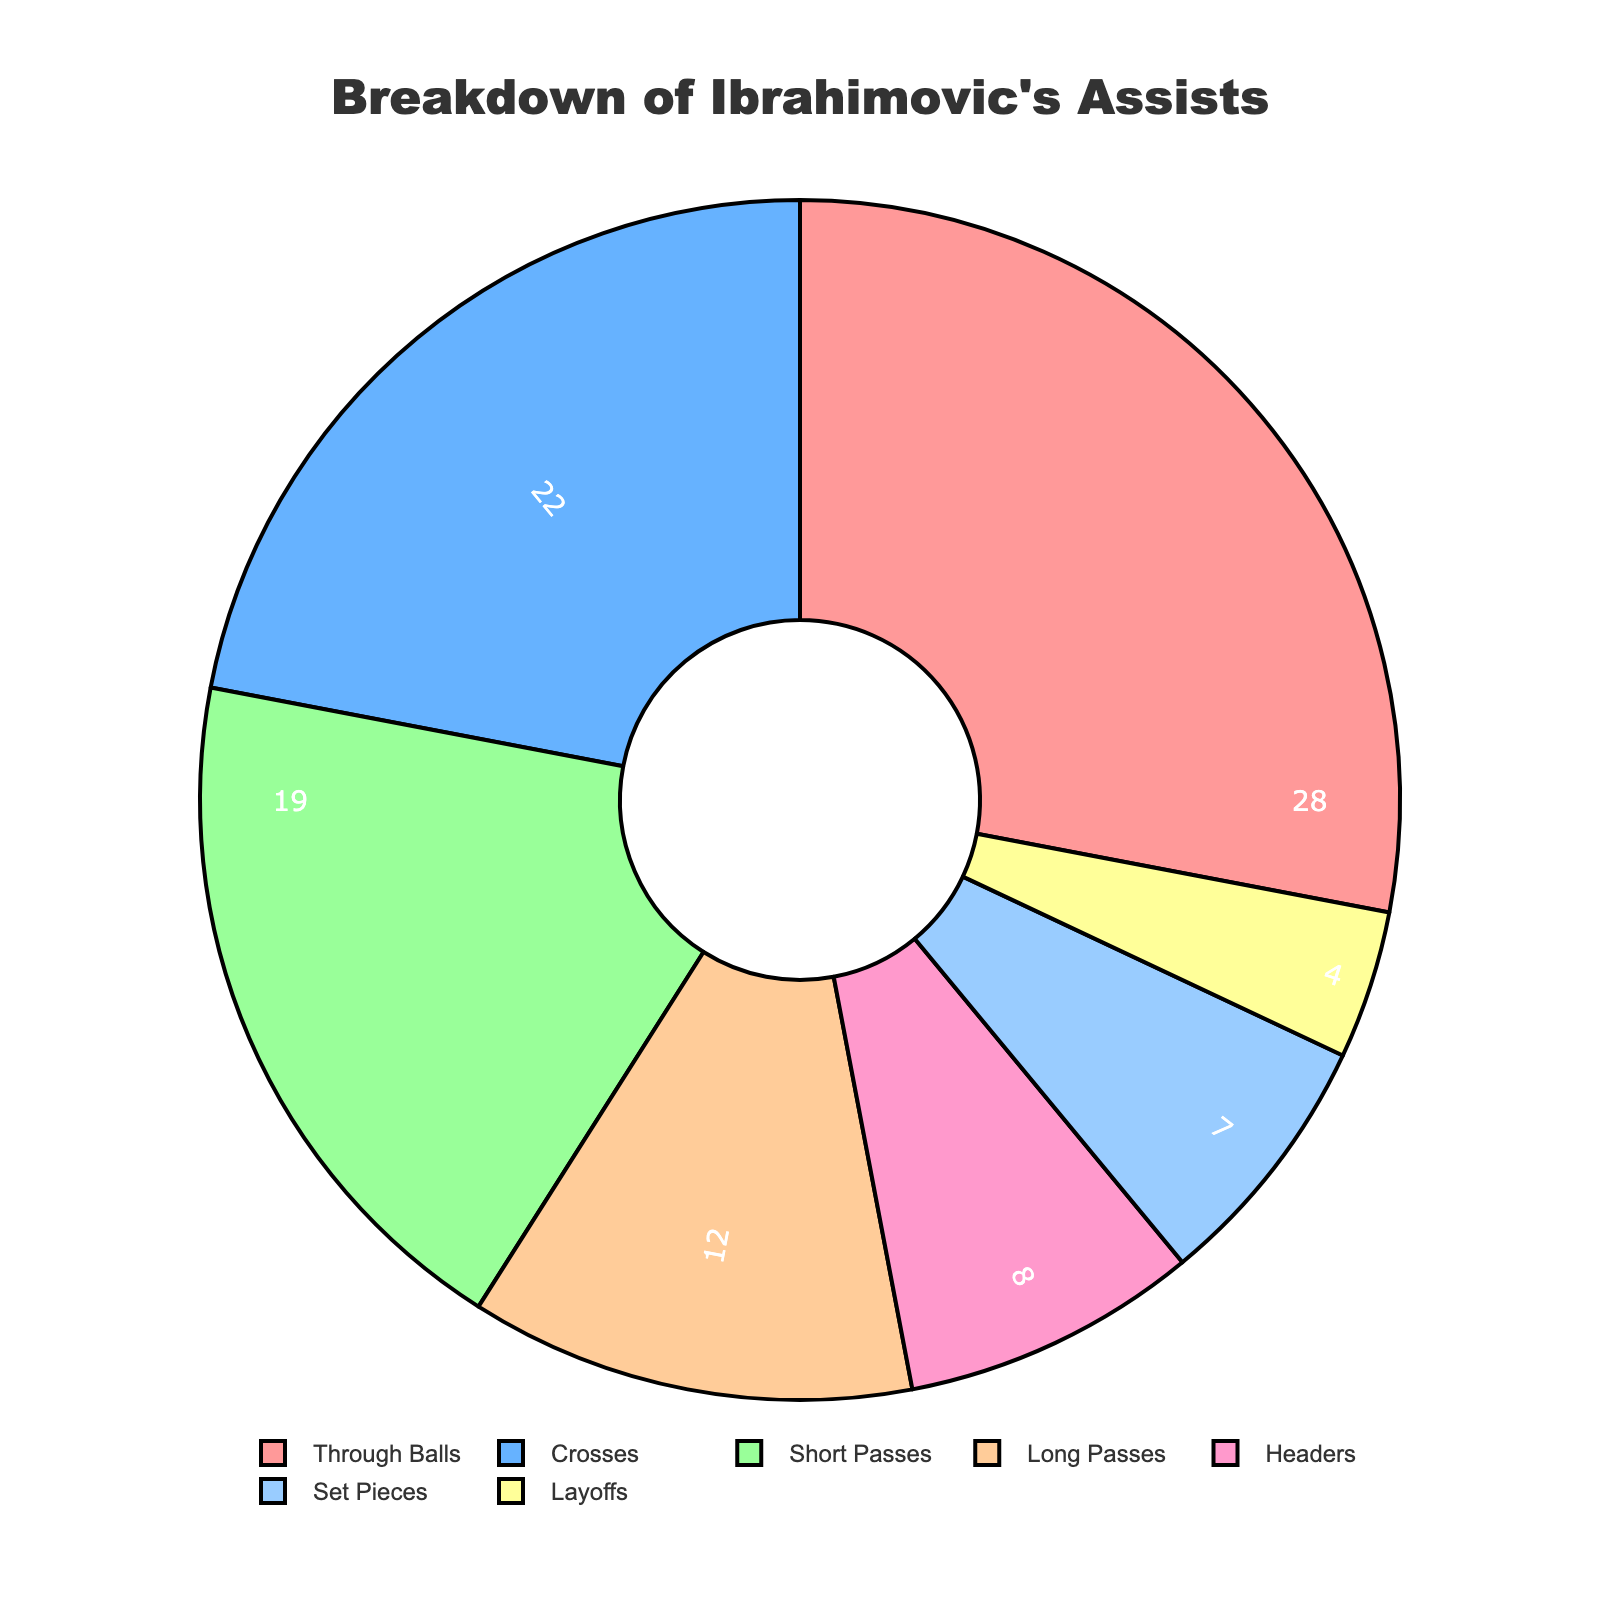Which type of assist does Ibrahimovic make the most? The pie chart shows the assist types with corresponding percentages. The largest segment represents "Through Balls" with 28%.
Answer: Through Balls Which assist type makes up the smallest percentage of Ibrahimovic's assists? By examining the pie chart, the smallest segment corresponds to "Layoffs" at 4%.
Answer: Layoffs How do the percentages of Through Balls and Crosses compare? The pie chart shows Through Balls at 28% and Crosses at 22%. Subtract 22 from 28 to compare.
Answer: Through Balls are 6% more What is the combined percentage of Short Passes and Long Passes? The pie chart shows Short Passes at 19% and Long Passes at 12%. Adding them together, 19 + 12 = 31%.
Answer: 31% Is the percentage of Headers greater than Set Pieces? The pie chart indicates Headers at 8% and Set Pieces at 7%. Comparing these values, 8% is greater than 7%.
Answer: Yes Which colors are used to represent Through Balls and Crosses? The color scheme assigns distinct colors to each assist type. Through Balls are represented in red, and Crosses in blue.
Answer: Red for Through Balls, Blue for Crosses What percentage of assists come from either Set Pieces or Layoffs? The pie chart shows Set Pieces at 7% and Layoffs at 4%. Adding these together, 7 + 4 = 11%.
Answer: 11% Are Short Passes and Long Passes collectively more or less frequent than Through Balls? Short Passes are 19% and Long Passes are 12%, combined to 31%. Through Balls are 28%. Comparing 31% to 28%, they are more frequent.
Answer: More frequent By how much does the percentage of Headers differ from Layoffs? Headers account for 8% of assists, while Layoffs account for 4%. Subtracting 4 from 8 gives a difference of 4%.
Answer: 4% Which two types of assists together make up exactly 50% of Ibrahimovic's assists? Adding the percentages of Through Balls (28%) and Crosses (22%) provides the exact total of 50%.
Answer: Through Balls and Crosses 